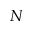Convert formula to latex. <formula><loc_0><loc_0><loc_500><loc_500>N</formula> 